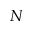Convert formula to latex. <formula><loc_0><loc_0><loc_500><loc_500>N</formula> 